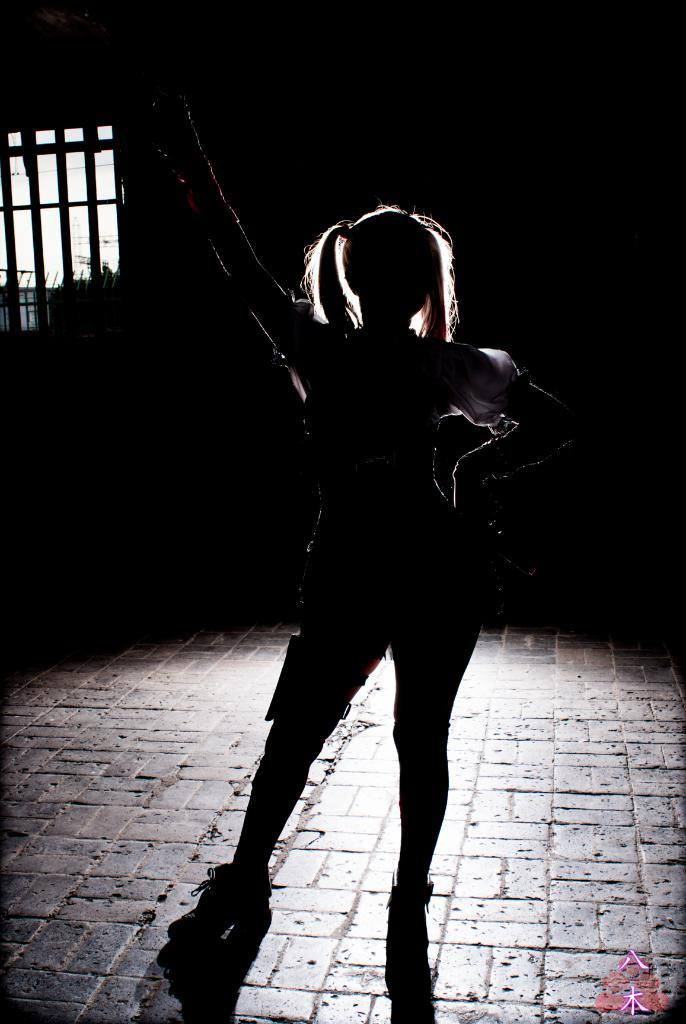Who is the main subject in the image? There is a girl in the image. What is the girl doing in the image? The girl is standing on the floor and raising her hand. What can be seen in the background of the image? There is a window visible in the background of the image. What type of mountain can be seen in the image? There is no mountain present in the image; it only features a girl standing on the floor and raising her hand, with a window visible in the background. 